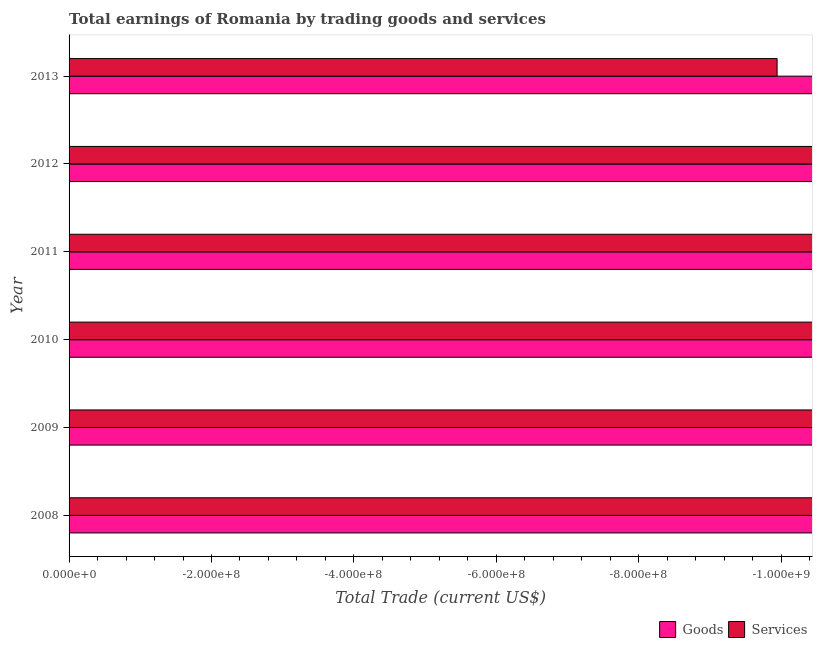How many different coloured bars are there?
Give a very brief answer. 0. Are the number of bars per tick equal to the number of legend labels?
Ensure brevity in your answer.  No. Are the number of bars on each tick of the Y-axis equal?
Provide a short and direct response. Yes. What is the label of the 2nd group of bars from the top?
Keep it short and to the point. 2012. What is the difference between the amount earned by trading goods in 2008 and the amount earned by trading services in 2010?
Offer a very short reply. 0. In how many years, is the amount earned by trading services greater than the average amount earned by trading services taken over all years?
Keep it short and to the point. 0. What is the difference between two consecutive major ticks on the X-axis?
Provide a succinct answer. 2.00e+08. Are the values on the major ticks of X-axis written in scientific E-notation?
Provide a succinct answer. Yes. Does the graph contain any zero values?
Your answer should be very brief. Yes. How are the legend labels stacked?
Make the answer very short. Horizontal. What is the title of the graph?
Keep it short and to the point. Total earnings of Romania by trading goods and services. What is the label or title of the X-axis?
Give a very brief answer. Total Trade (current US$). What is the label or title of the Y-axis?
Your answer should be compact. Year. What is the Total Trade (current US$) of Goods in 2008?
Provide a short and direct response. 0. What is the Total Trade (current US$) in Services in 2008?
Your answer should be very brief. 0. What is the Total Trade (current US$) of Goods in 2009?
Provide a short and direct response. 0. What is the Total Trade (current US$) of Services in 2009?
Keep it short and to the point. 0. What is the Total Trade (current US$) in Goods in 2010?
Give a very brief answer. 0. What is the Total Trade (current US$) of Services in 2010?
Your response must be concise. 0. What is the Total Trade (current US$) in Goods in 2011?
Provide a short and direct response. 0. What is the Total Trade (current US$) in Services in 2011?
Provide a short and direct response. 0. What is the Total Trade (current US$) in Goods in 2012?
Ensure brevity in your answer.  0. What is the total Total Trade (current US$) in Goods in the graph?
Your answer should be compact. 0. What is the total Total Trade (current US$) in Services in the graph?
Give a very brief answer. 0. What is the average Total Trade (current US$) of Goods per year?
Your response must be concise. 0. 